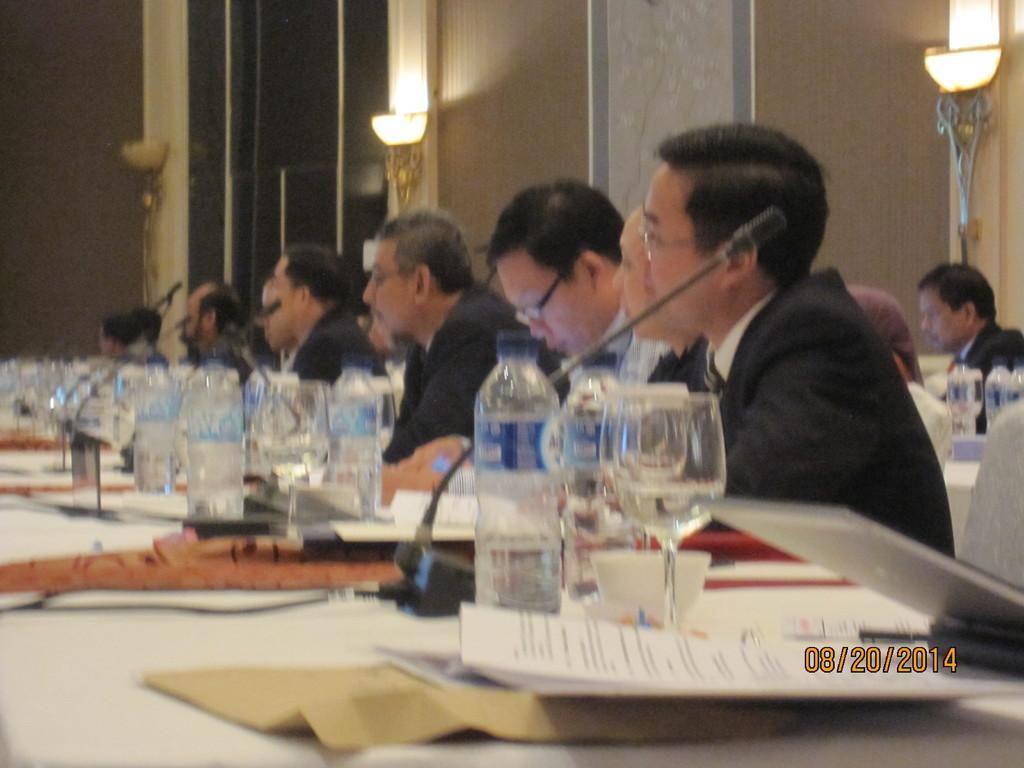Please provide a concise description of this image. In this image there is a table, on that table there are papers, mike's, water bottles and glasses, beside the table there are people sitting on chairs, in the background there is a wall, for that wall there are lights, in the bottom right there is date. 